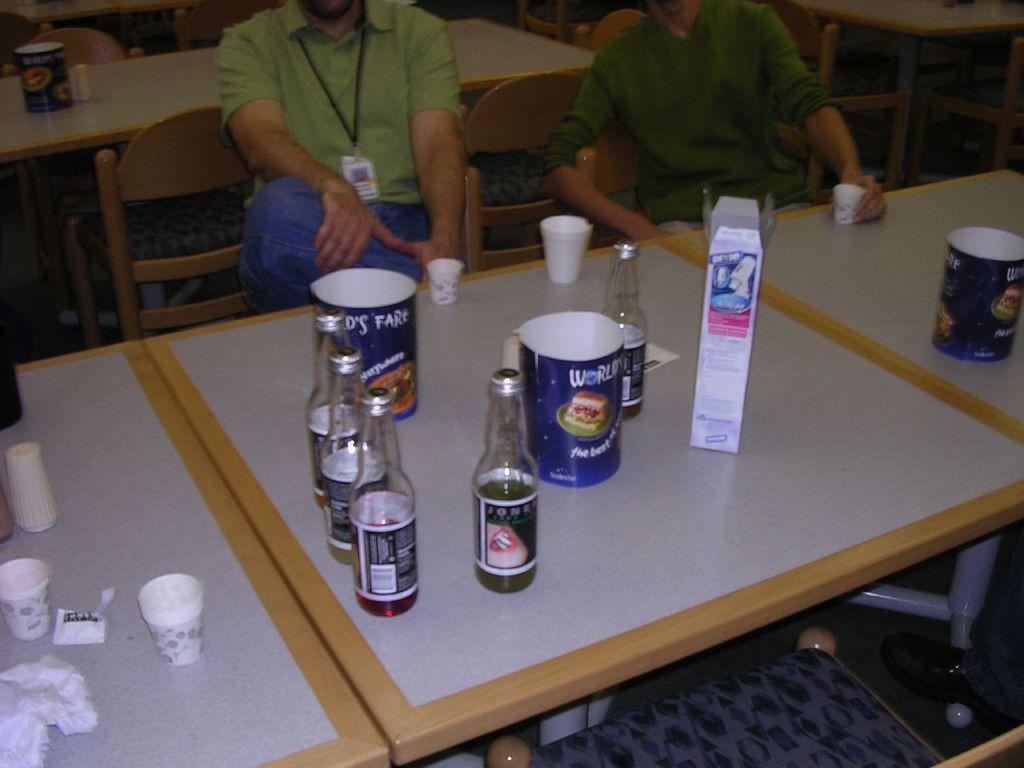In one or two sentences, can you explain what this image depicts? This image is taken inside a room. In this image two men are sitting on the chairs. In the middle of the image there is a table with few bottles and cups on it. In the background there are few empty chairs and tables. 